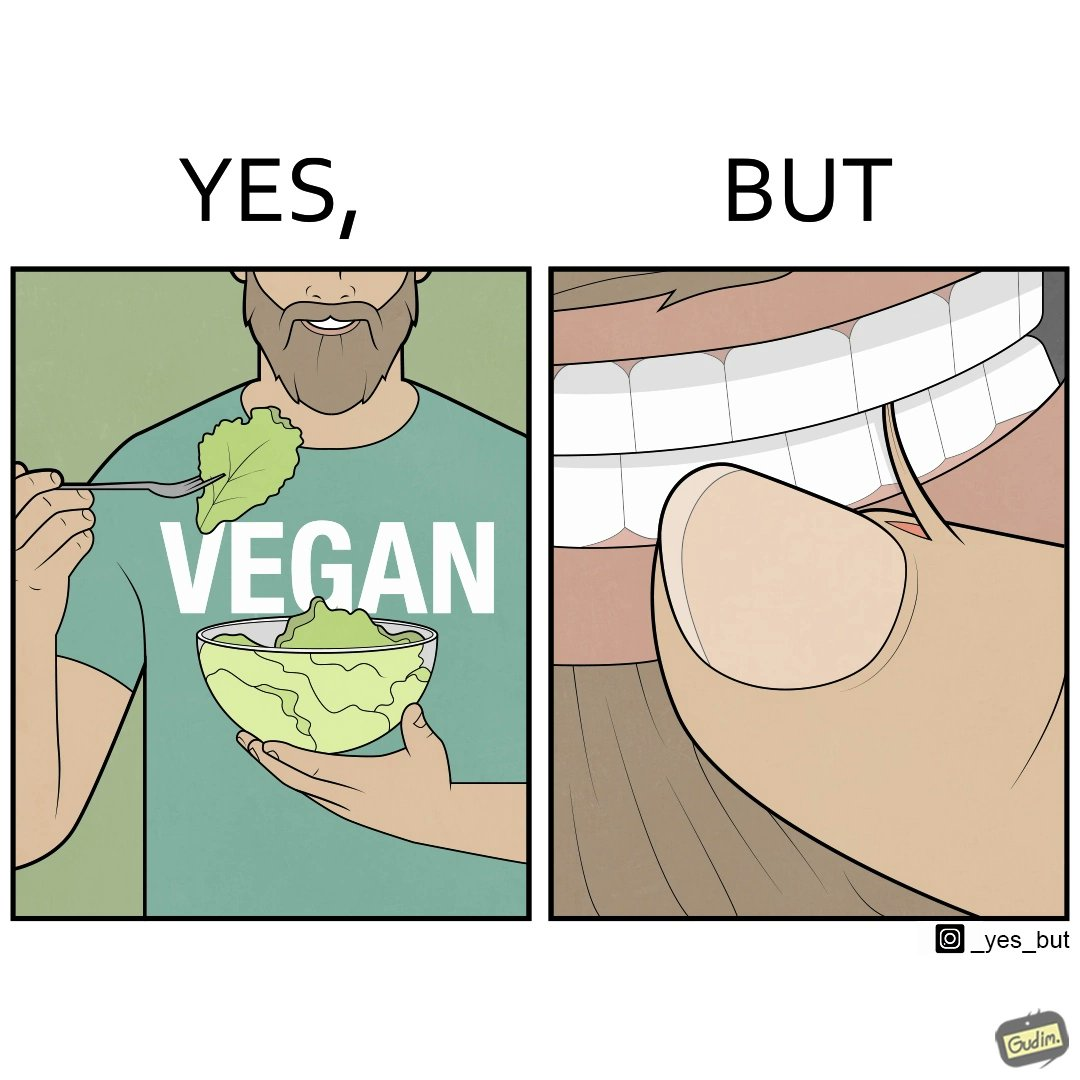What is shown in the left half versus the right half of this image? In the left part of the image: The image shows a man eating leafy vegetables out of a bowl in his hand. He is also wearing a t-shirt that says vegan. In the right part of the image: The image shows a person biting the skin around the fingernails of thier hand. 